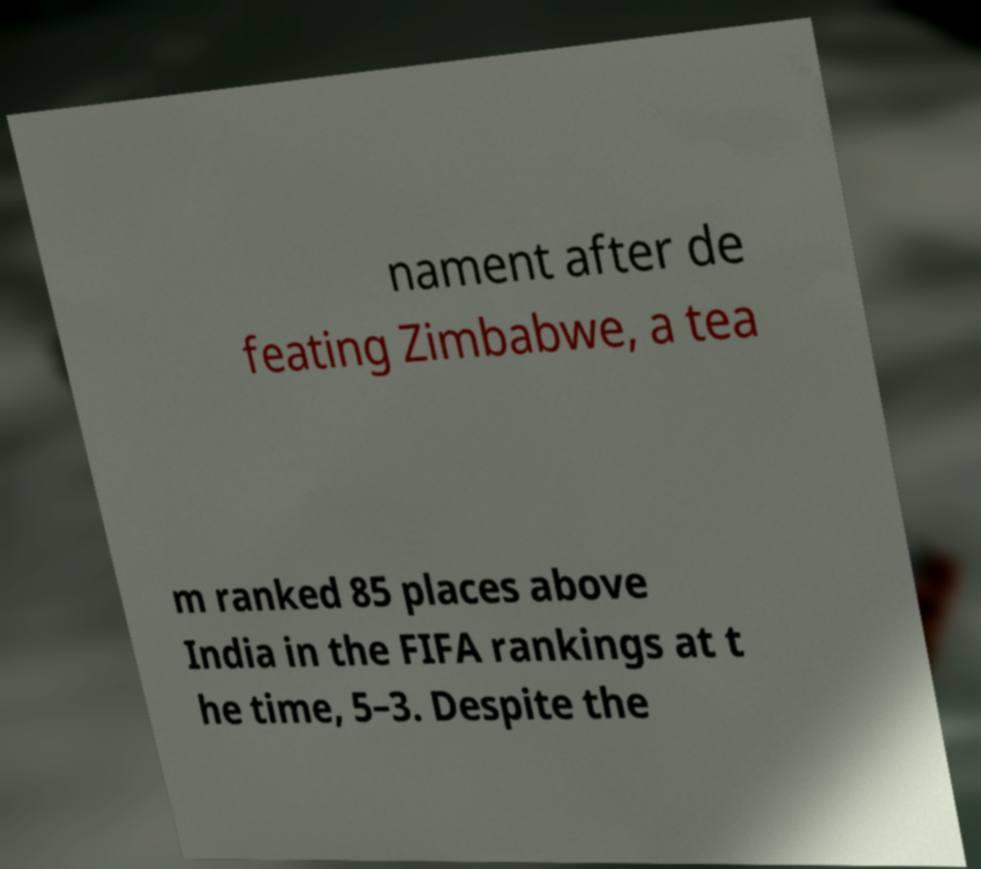Could you assist in decoding the text presented in this image and type it out clearly? nament after de feating Zimbabwe, a tea m ranked 85 places above India in the FIFA rankings at t he time, 5–3. Despite the 